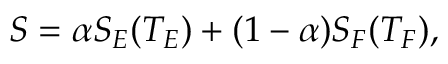<formula> <loc_0><loc_0><loc_500><loc_500>S = \alpha S _ { E } ( T _ { E } ) + ( 1 - \alpha ) S _ { F } ( T _ { F } ) ,</formula> 